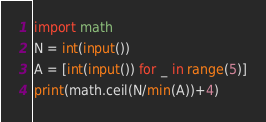Convert code to text. <code><loc_0><loc_0><loc_500><loc_500><_Python_>import math
N = int(input())
A = [int(input()) for _ in range(5)]
print(math.ceil(N/min(A))+4)
</code> 